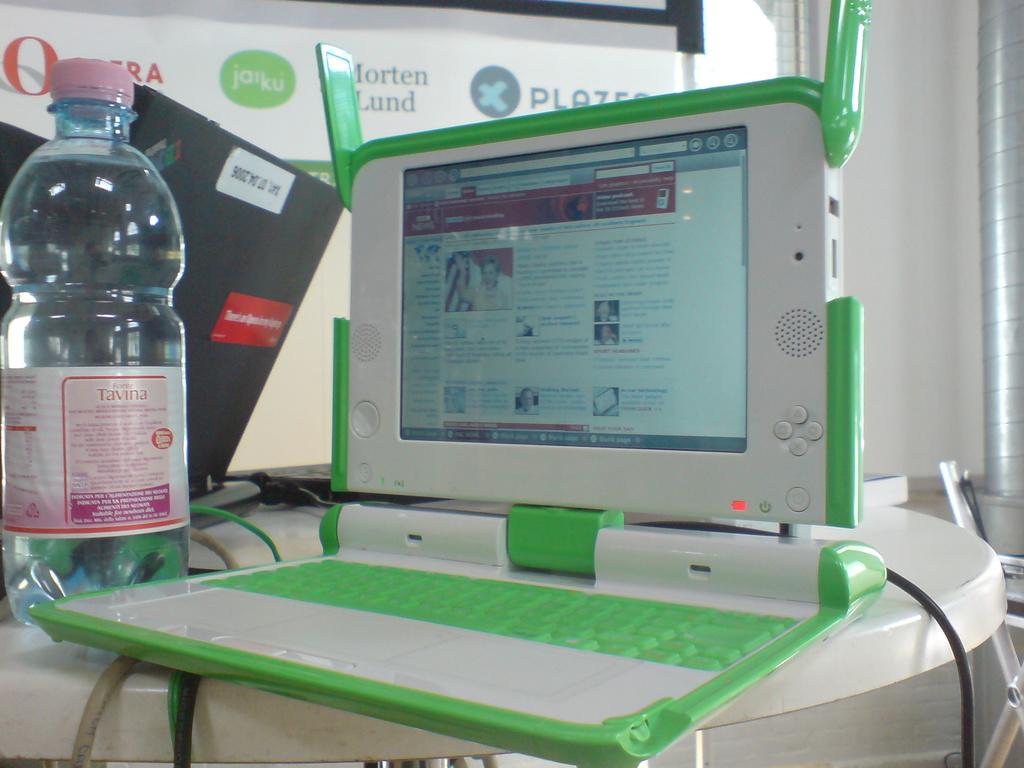What is the word which forms of the title on the red box on the wayer bottle?
Ensure brevity in your answer.  Tavina. 